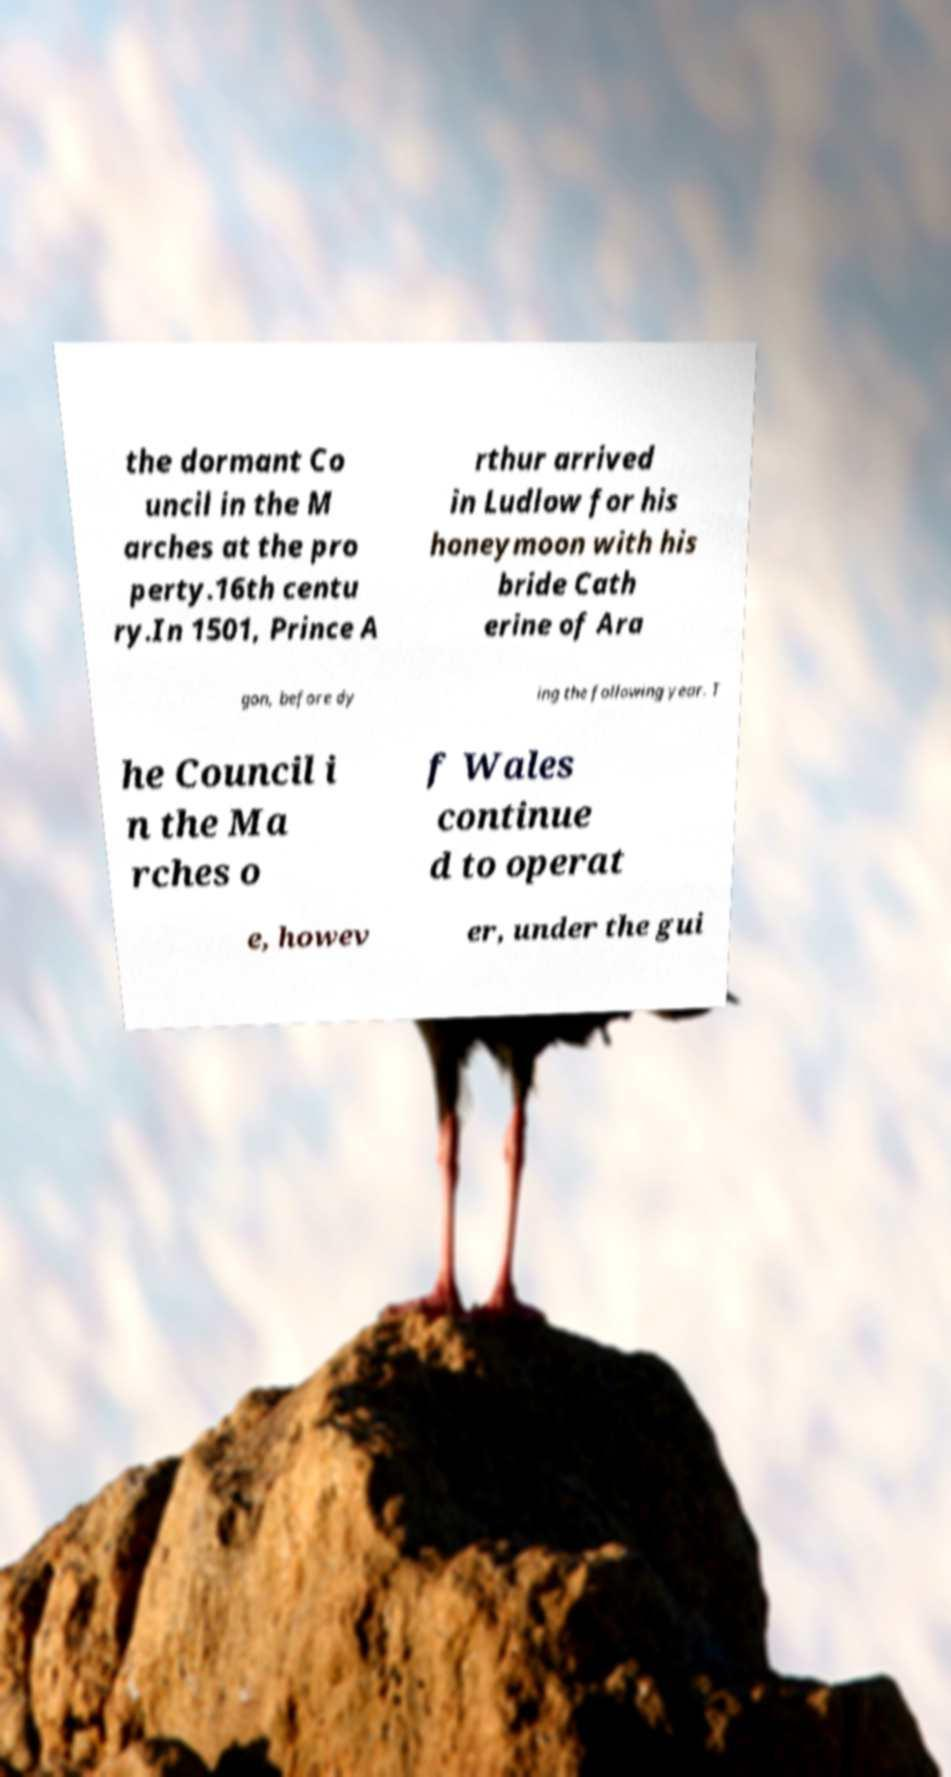Could you assist in decoding the text presented in this image and type it out clearly? the dormant Co uncil in the M arches at the pro perty.16th centu ry.In 1501, Prince A rthur arrived in Ludlow for his honeymoon with his bride Cath erine of Ara gon, before dy ing the following year. T he Council i n the Ma rches o f Wales continue d to operat e, howev er, under the gui 